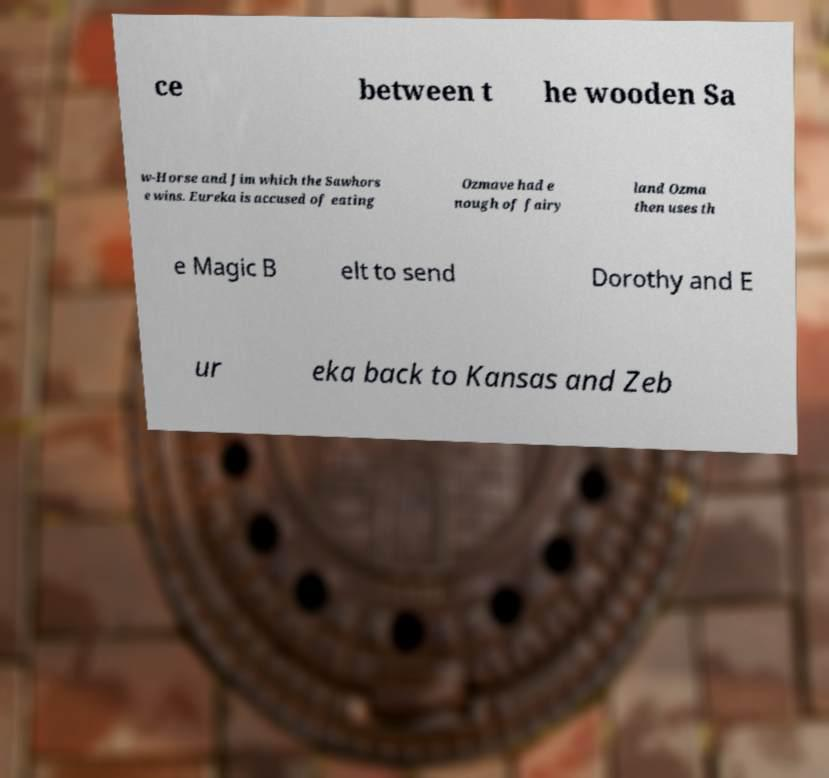Please read and relay the text visible in this image. What does it say? ce between t he wooden Sa w-Horse and Jim which the Sawhors e wins. Eureka is accused of eating Ozmave had e nough of fairy land Ozma then uses th e Magic B elt to send Dorothy and E ur eka back to Kansas and Zeb 